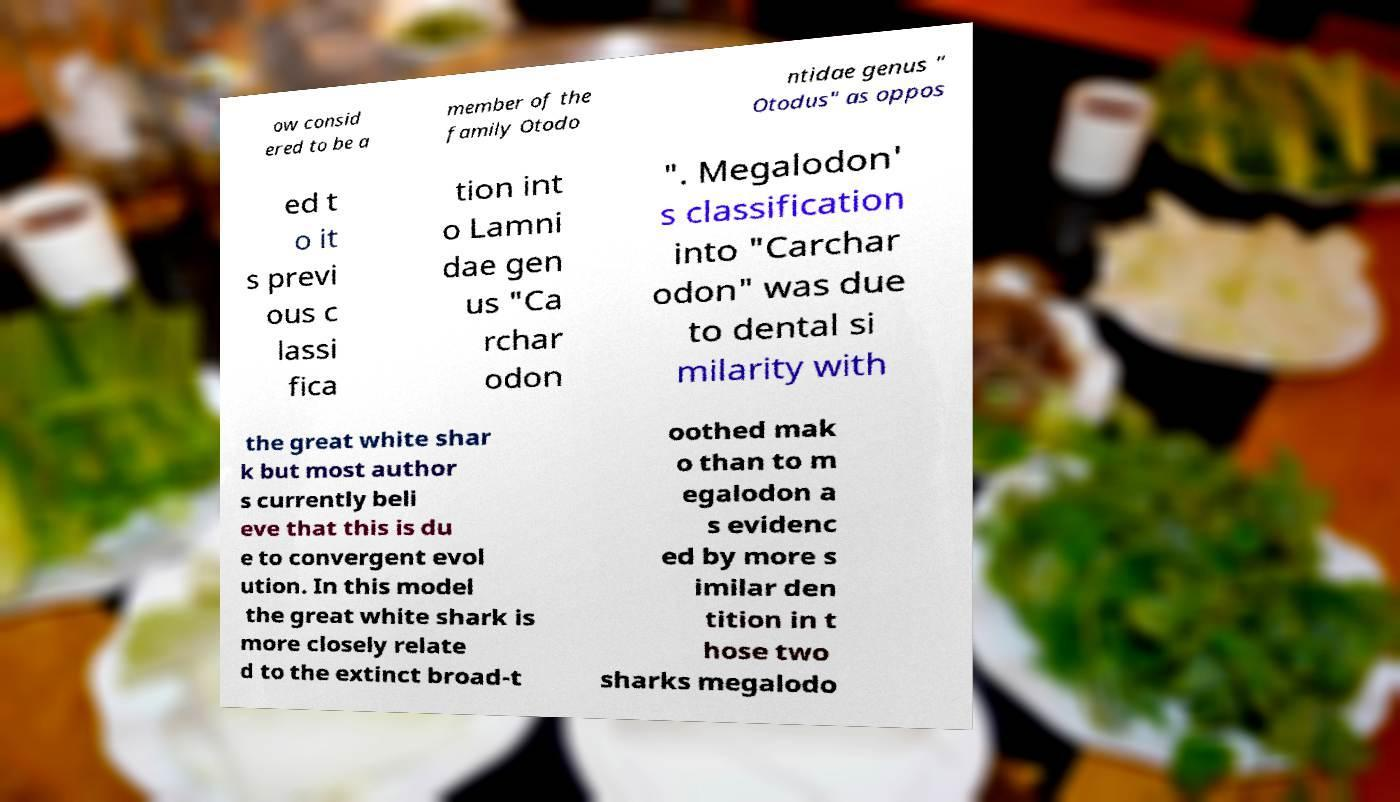Please identify and transcribe the text found in this image. ow consid ered to be a member of the family Otodo ntidae genus " Otodus" as oppos ed t o it s previ ous c lassi fica tion int o Lamni dae gen us "Ca rchar odon ". Megalodon' s classification into "Carchar odon" was due to dental si milarity with the great white shar k but most author s currently beli eve that this is du e to convergent evol ution. In this model the great white shark is more closely relate d to the extinct broad-t oothed mak o than to m egalodon a s evidenc ed by more s imilar den tition in t hose two sharks megalodo 